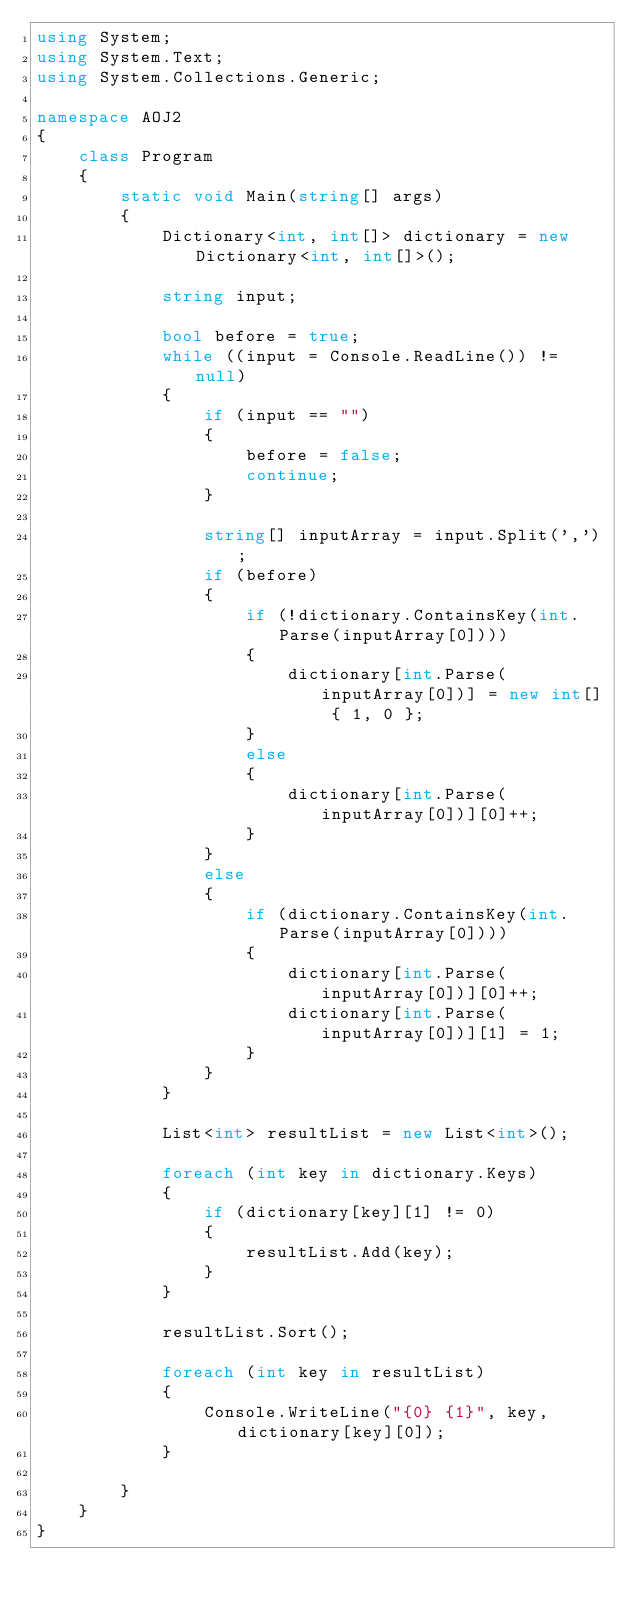Convert code to text. <code><loc_0><loc_0><loc_500><loc_500><_C#_>using System;
using System.Text;
using System.Collections.Generic;

namespace AOJ2
{
    class Program
    {
        static void Main(string[] args)
        {
            Dictionary<int, int[]> dictionary = new Dictionary<int, int[]>();

            string input;

            bool before = true;
            while ((input = Console.ReadLine()) != null)
            {
                if (input == "")
                {
                    before = false;
                    continue;
                }

                string[] inputArray = input.Split(',');
                if (before)
                {
                    if (!dictionary.ContainsKey(int.Parse(inputArray[0])))
                    {
                        dictionary[int.Parse(inputArray[0])] = new int[] { 1, 0 };
                    }
                    else
                    {
                        dictionary[int.Parse(inputArray[0])][0]++;
                    }
                }
                else
                {
                    if (dictionary.ContainsKey(int.Parse(inputArray[0])))
                    {
                        dictionary[int.Parse(inputArray[0])][0]++;
                        dictionary[int.Parse(inputArray[0])][1] = 1;
                    }
                }
            }

            List<int> resultList = new List<int>();

            foreach (int key in dictionary.Keys)
            {
                if (dictionary[key][1] != 0)
                {
                    resultList.Add(key);
                }
            }

            resultList.Sort();

            foreach (int key in resultList)
            {
                Console.WriteLine("{0} {1}", key, dictionary[key][0]);
            }

        }
    }
}</code> 